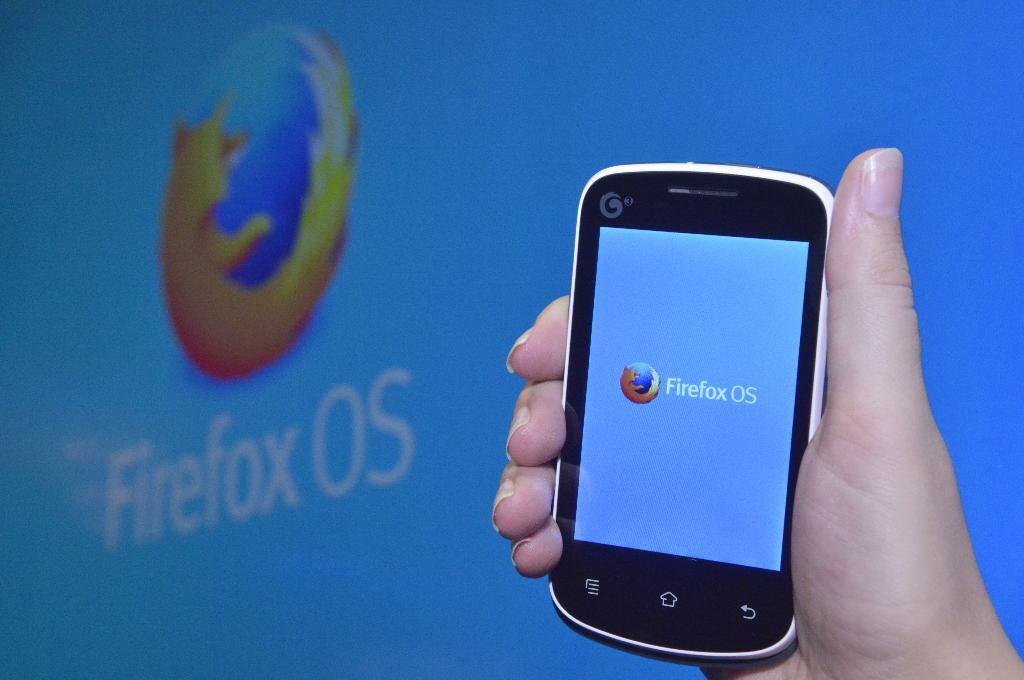<image>
Summarize the visual content of the image. a phone that has the term Firefox on it 